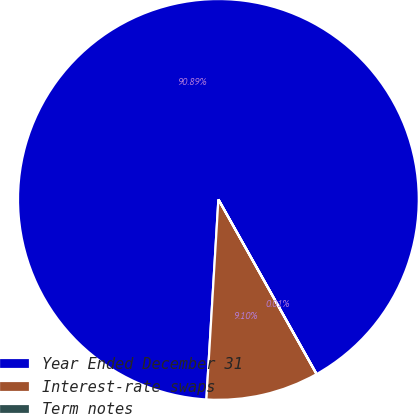<chart> <loc_0><loc_0><loc_500><loc_500><pie_chart><fcel>Year Ended December 31<fcel>Interest-rate swaps<fcel>Term notes<nl><fcel>90.89%<fcel>9.1%<fcel>0.01%<nl></chart> 